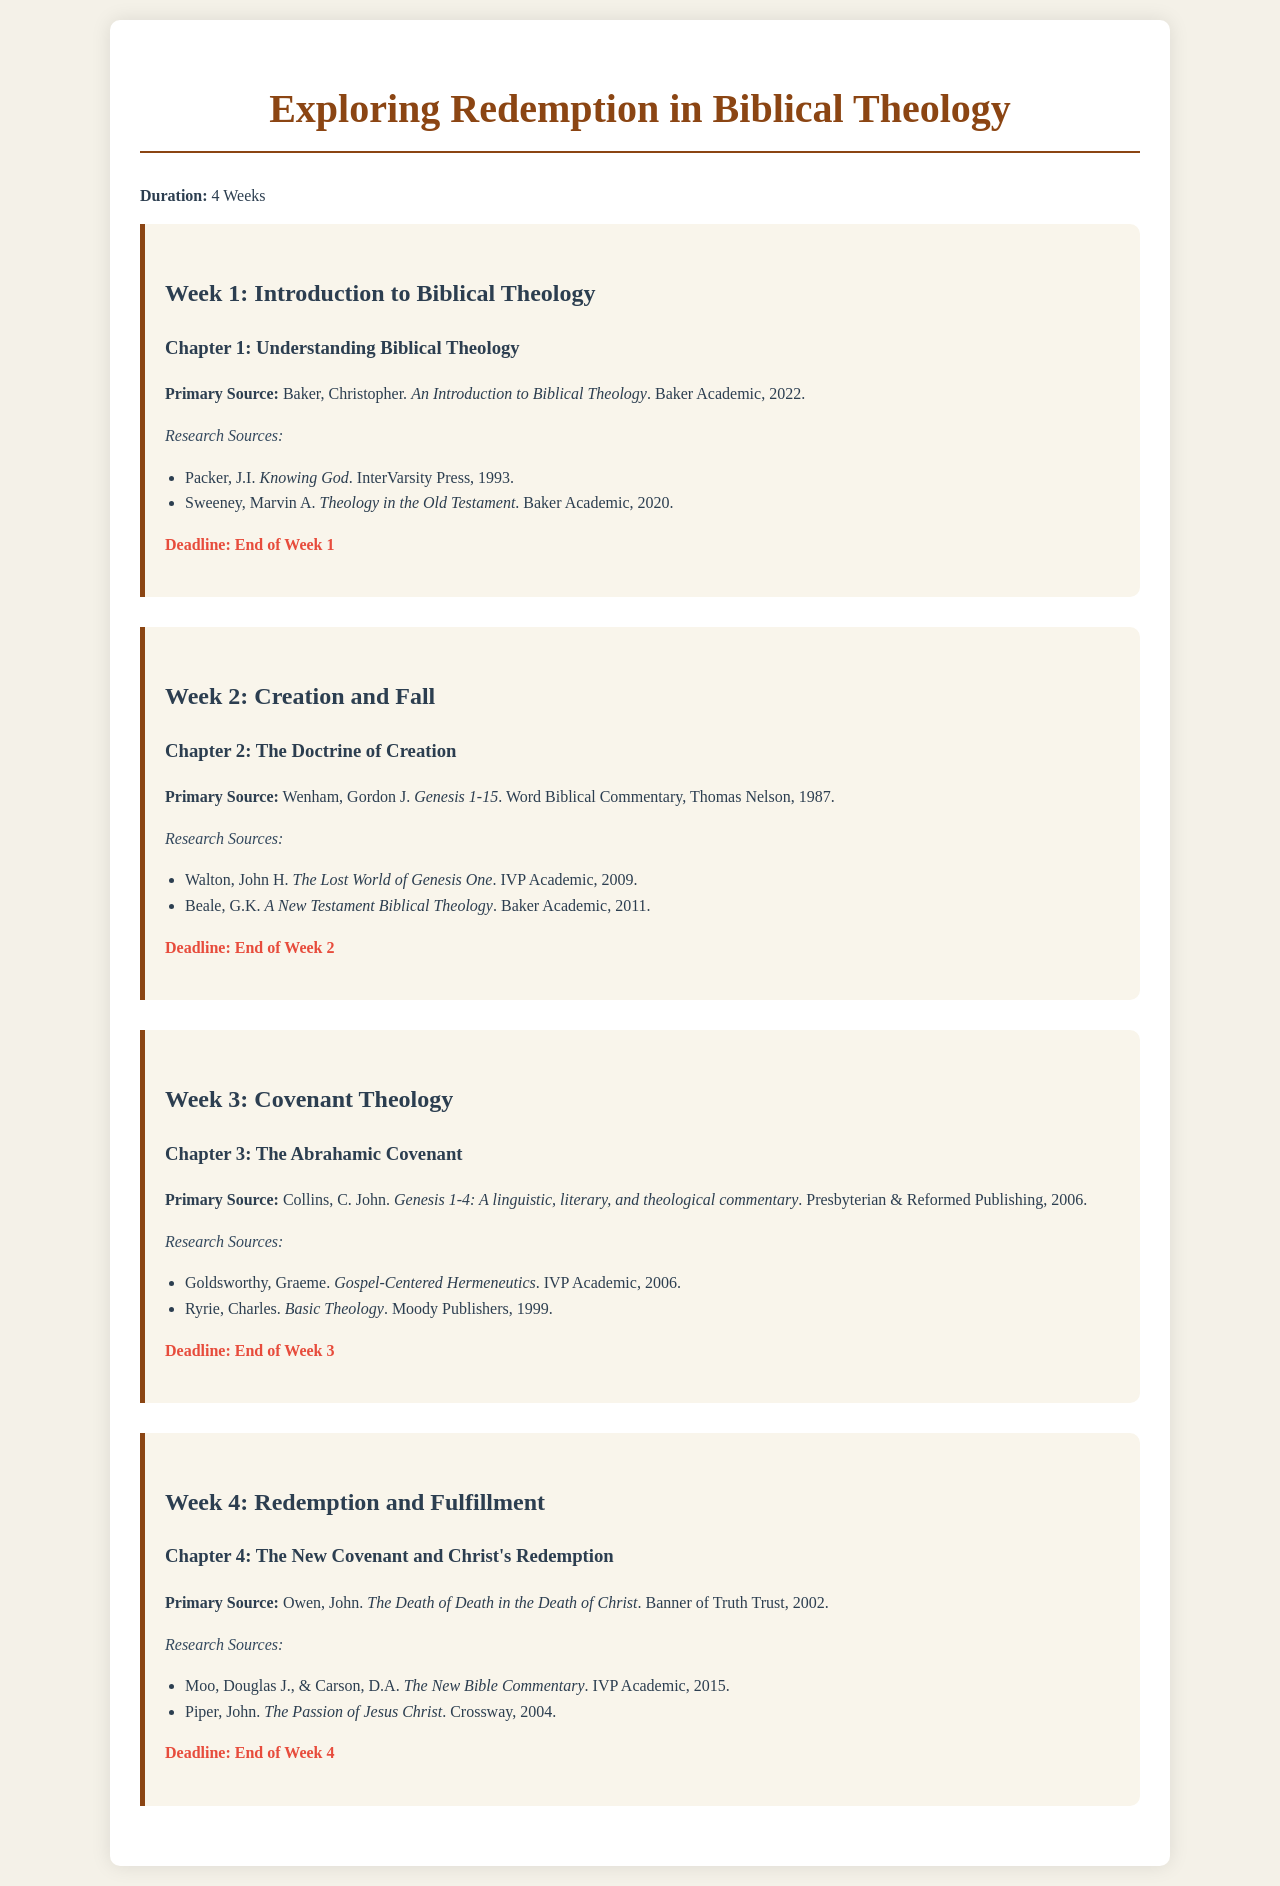What is the title of the project? The title of the project is stated prominently at the beginning of the document.
Answer: Exploring Redemption in Biblical Theology How many weeks does the study schedule cover? The duration of the study schedule is mentioned clearly in the first paragraph of the document.
Answer: 4 Weeks What is the primary source for Chapter 1? The primary source for Chapter 1 is identified under each chapter breakdown.
Answer: Baker, Christopher. An Introduction to Biblical Theology What is due at the end of Week 3? The schedule specifies deadlines at the end of each week for completion.
Answer: Chapter 3: The Abrahamic Covenant Which book is the primary source for the chapter on the New Covenant? Each chapter has a designated primary source listed.
Answer: Owen, John. The Death of Death in the Death of Christ Name one research source for Chapter 2. Research sources are listed for each chapter as additional materials.
Answer: Walton, John H. The Lost World of Genesis One What theological concept does Chapter 3 focus on? The chapter topics focus on specific theological concepts presented in the headings.
Answer: The Abrahamic Covenant What is the deadline for the work in Week 1? The deadline for each chapter is specified at the end of the chapter section.
Answer: End of Week 1 